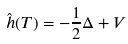<formula> <loc_0><loc_0><loc_500><loc_500>\hat { h } ( T ) = - \frac { 1 } { 2 } \Delta + V</formula> 